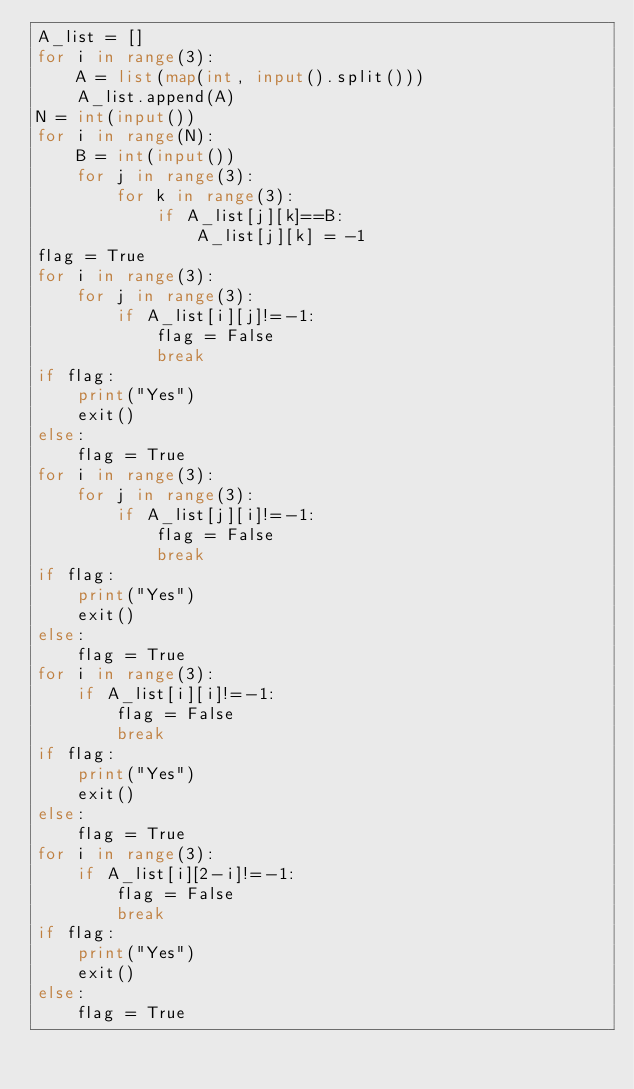<code> <loc_0><loc_0><loc_500><loc_500><_Python_>A_list = []
for i in range(3):
    A = list(map(int, input().split()))
    A_list.append(A)
N = int(input())
for i in range(N):
    B = int(input())
    for j in range(3):
        for k in range(3):
            if A_list[j][k]==B:
                A_list[j][k] = -1
flag = True
for i in range(3):
    for j in range(3):
        if A_list[i][j]!=-1:
            flag = False
            break
if flag:
    print("Yes")
    exit()
else:
    flag = True
for i in range(3):
    for j in range(3):
        if A_list[j][i]!=-1:
            flag = False
            break
if flag:
    print("Yes")
    exit()
else:
    flag = True
for i in range(3):
    if A_list[i][i]!=-1:
        flag = False
        break
if flag:
    print("Yes")
    exit()
else:
    flag = True
for i in range(3):
    if A_list[i][2-i]!=-1:
        flag = False
        break
if flag:
    print("Yes")
    exit()
else:
    flag = True</code> 